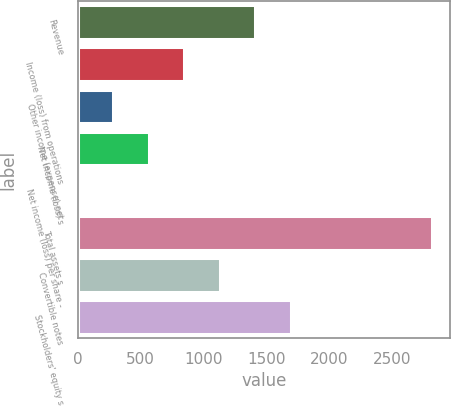Convert chart. <chart><loc_0><loc_0><loc_500><loc_500><bar_chart><fcel>Revenue<fcel>Income (loss) from operations<fcel>Other income (expense) net<fcel>Net income (loss) s<fcel>Net income (loss) per share -<fcel>Total assets s<fcel>Convertible notes<fcel>Stockholders' equity s<nl><fcel>1408.97<fcel>845.41<fcel>281.85<fcel>563.63<fcel>0.07<fcel>2817.9<fcel>1127.19<fcel>1690.75<nl></chart> 